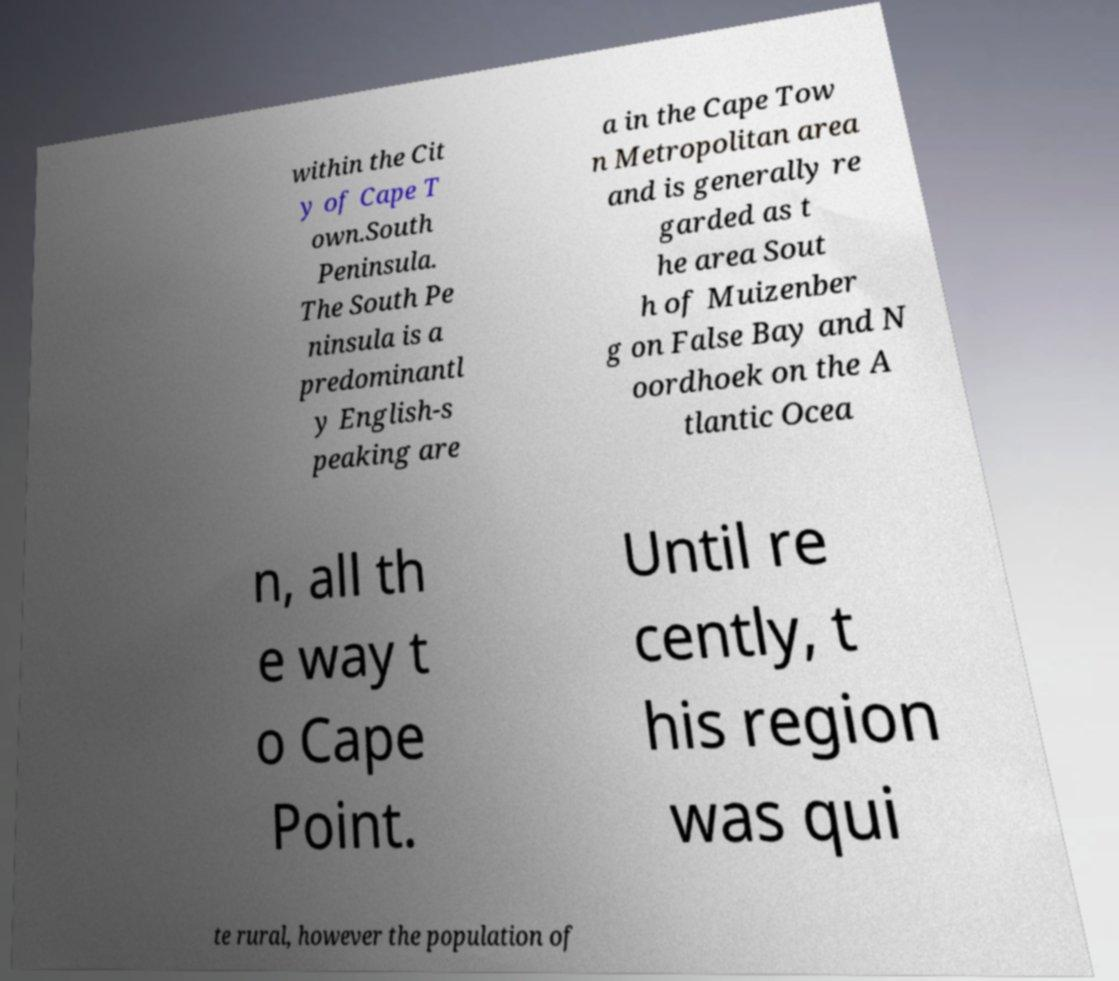Can you read and provide the text displayed in the image?This photo seems to have some interesting text. Can you extract and type it out for me? within the Cit y of Cape T own.South Peninsula. The South Pe ninsula is a predominantl y English-s peaking are a in the Cape Tow n Metropolitan area and is generally re garded as t he area Sout h of Muizenber g on False Bay and N oordhoek on the A tlantic Ocea n, all th e way t o Cape Point. Until re cently, t his region was qui te rural, however the population of 